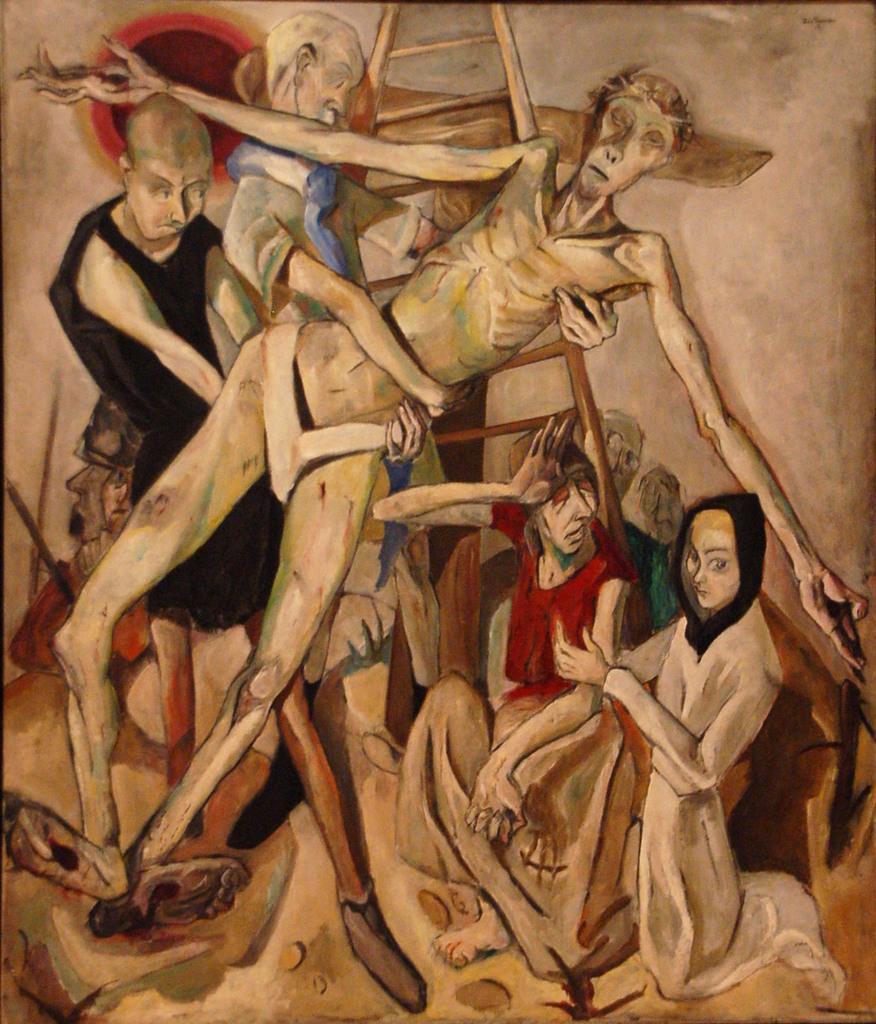Please provide a concise description of this image. In this image we can see the painting of some people and a ladder. 